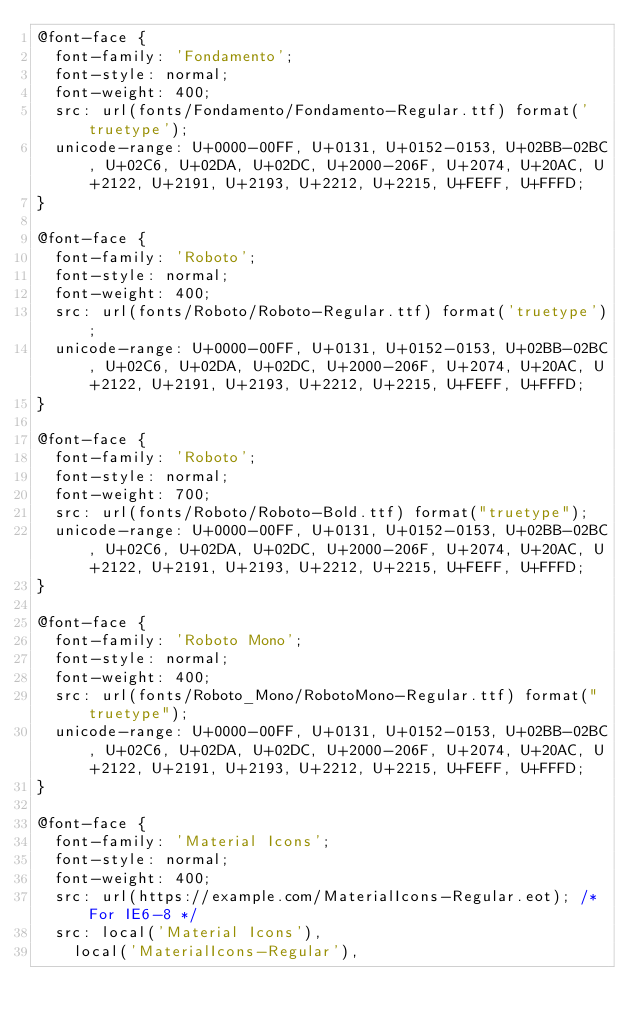<code> <loc_0><loc_0><loc_500><loc_500><_CSS_>@font-face {
  font-family: 'Fondamento';
  font-style: normal;
  font-weight: 400;
  src: url(fonts/Fondamento/Fondamento-Regular.ttf) format('truetype');
  unicode-range: U+0000-00FF, U+0131, U+0152-0153, U+02BB-02BC, U+02C6, U+02DA, U+02DC, U+2000-206F, U+2074, U+20AC, U+2122, U+2191, U+2193, U+2212, U+2215, U+FEFF, U+FFFD;
}

@font-face {
  font-family: 'Roboto';
  font-style: normal;
  font-weight: 400;
  src: url(fonts/Roboto/Roboto-Regular.ttf) format('truetype');
  unicode-range: U+0000-00FF, U+0131, U+0152-0153, U+02BB-02BC, U+02C6, U+02DA, U+02DC, U+2000-206F, U+2074, U+20AC, U+2122, U+2191, U+2193, U+2212, U+2215, U+FEFF, U+FFFD;
}

@font-face {
  font-family: 'Roboto';
  font-style: normal;
  font-weight: 700;
  src: url(fonts/Roboto/Roboto-Bold.ttf) format("truetype");
  unicode-range: U+0000-00FF, U+0131, U+0152-0153, U+02BB-02BC, U+02C6, U+02DA, U+02DC, U+2000-206F, U+2074, U+20AC, U+2122, U+2191, U+2193, U+2212, U+2215, U+FEFF, U+FFFD;
}

@font-face {
  font-family: 'Roboto Mono';
  font-style: normal;
  font-weight: 400;
  src: url(fonts/Roboto_Mono/RobotoMono-Regular.ttf) format("truetype");
  unicode-range: U+0000-00FF, U+0131, U+0152-0153, U+02BB-02BC, U+02C6, U+02DA, U+02DC, U+2000-206F, U+2074, U+20AC, U+2122, U+2191, U+2193, U+2212, U+2215, U+FEFF, U+FFFD;
}

@font-face {
  font-family: 'Material Icons';
  font-style: normal;
  font-weight: 400;
  src: url(https://example.com/MaterialIcons-Regular.eot); /* For IE6-8 */
  src: local('Material Icons'),
    local('MaterialIcons-Regular'),</code> 